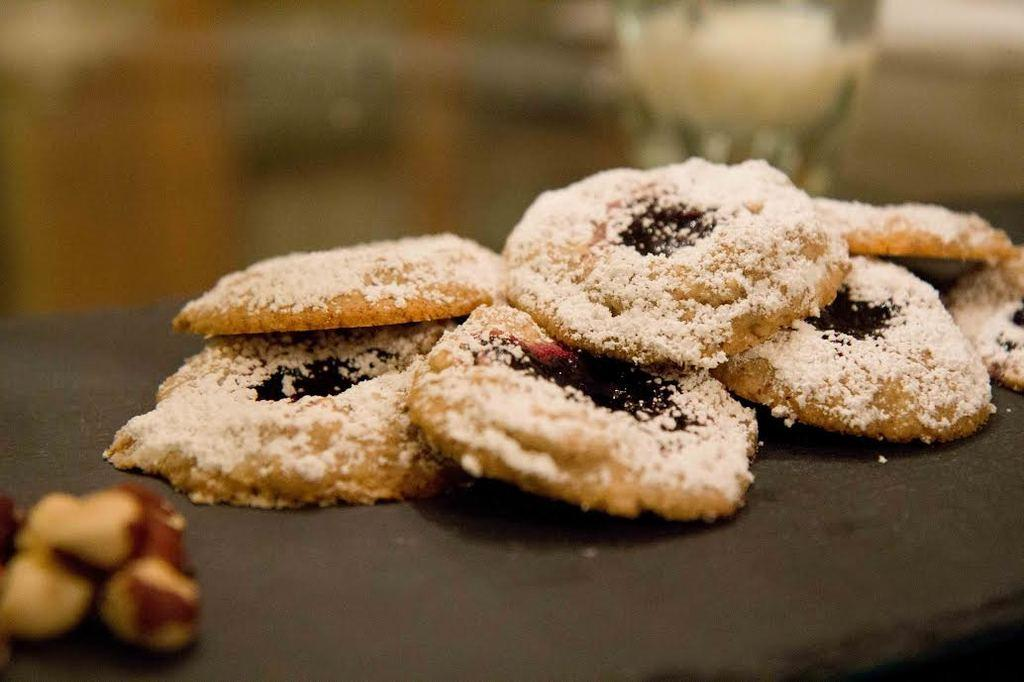What is the main subject of the image? The main subject of the image is food. Where is the food located? The food is on an object. Can you describe the background of the image? The background of the image is blurred. Can you see any sparks coming from the food in the image? There are no sparks present in the image. How does the trail of the food appear in the image? There is no trail associated with the food in the image. 